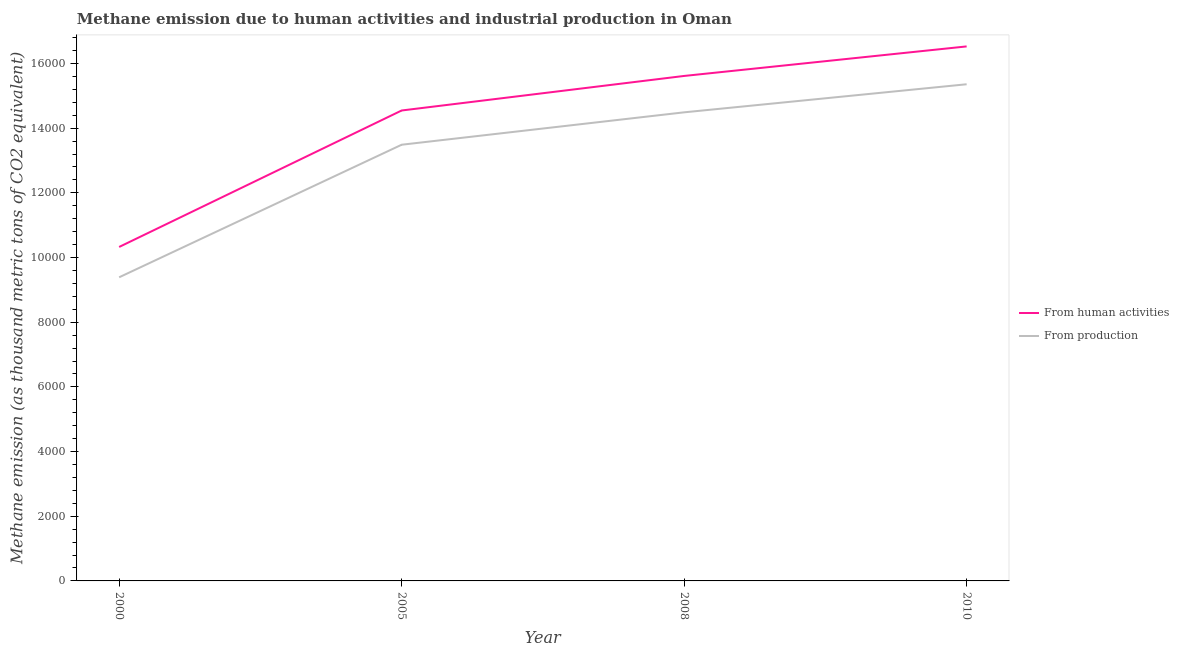Is the number of lines equal to the number of legend labels?
Provide a short and direct response. Yes. What is the amount of emissions from human activities in 2008?
Your answer should be compact. 1.56e+04. Across all years, what is the maximum amount of emissions generated from industries?
Make the answer very short. 1.54e+04. Across all years, what is the minimum amount of emissions from human activities?
Your answer should be compact. 1.03e+04. In which year was the amount of emissions generated from industries maximum?
Your response must be concise. 2010. What is the total amount of emissions from human activities in the graph?
Ensure brevity in your answer.  5.70e+04. What is the difference between the amount of emissions generated from industries in 2000 and that in 2005?
Ensure brevity in your answer.  -4099. What is the difference between the amount of emissions generated from industries in 2000 and the amount of emissions from human activities in 2010?
Keep it short and to the point. -7138.8. What is the average amount of emissions generated from industries per year?
Provide a short and direct response. 1.32e+04. In the year 2000, what is the difference between the amount of emissions generated from industries and amount of emissions from human activities?
Make the answer very short. -937.9. In how many years, is the amount of emissions from human activities greater than 1600 thousand metric tons?
Your response must be concise. 4. What is the ratio of the amount of emissions generated from industries in 2000 to that in 2008?
Provide a succinct answer. 0.65. Is the amount of emissions generated from industries in 2000 less than that in 2010?
Keep it short and to the point. Yes. Is the difference between the amount of emissions from human activities in 2005 and 2008 greater than the difference between the amount of emissions generated from industries in 2005 and 2008?
Make the answer very short. No. What is the difference between the highest and the second highest amount of emissions generated from industries?
Provide a succinct answer. 868. What is the difference between the highest and the lowest amount of emissions from human activities?
Make the answer very short. 6200.9. In how many years, is the amount of emissions generated from industries greater than the average amount of emissions generated from industries taken over all years?
Your answer should be very brief. 3. Does the amount of emissions from human activities monotonically increase over the years?
Offer a very short reply. Yes. What is the difference between two consecutive major ticks on the Y-axis?
Provide a short and direct response. 2000. Does the graph contain grids?
Your response must be concise. No. What is the title of the graph?
Your answer should be compact. Methane emission due to human activities and industrial production in Oman. What is the label or title of the X-axis?
Provide a succinct answer. Year. What is the label or title of the Y-axis?
Your answer should be very brief. Methane emission (as thousand metric tons of CO2 equivalent). What is the Methane emission (as thousand metric tons of CO2 equivalent) of From human activities in 2000?
Offer a very short reply. 1.03e+04. What is the Methane emission (as thousand metric tons of CO2 equivalent) of From production in 2000?
Provide a succinct answer. 9388.4. What is the Methane emission (as thousand metric tons of CO2 equivalent) of From human activities in 2005?
Keep it short and to the point. 1.45e+04. What is the Methane emission (as thousand metric tons of CO2 equivalent) of From production in 2005?
Provide a succinct answer. 1.35e+04. What is the Methane emission (as thousand metric tons of CO2 equivalent) of From human activities in 2008?
Your answer should be compact. 1.56e+04. What is the Methane emission (as thousand metric tons of CO2 equivalent) in From production in 2008?
Keep it short and to the point. 1.45e+04. What is the Methane emission (as thousand metric tons of CO2 equivalent) of From human activities in 2010?
Ensure brevity in your answer.  1.65e+04. What is the Methane emission (as thousand metric tons of CO2 equivalent) in From production in 2010?
Your answer should be compact. 1.54e+04. Across all years, what is the maximum Methane emission (as thousand metric tons of CO2 equivalent) of From human activities?
Make the answer very short. 1.65e+04. Across all years, what is the maximum Methane emission (as thousand metric tons of CO2 equivalent) of From production?
Ensure brevity in your answer.  1.54e+04. Across all years, what is the minimum Methane emission (as thousand metric tons of CO2 equivalent) of From human activities?
Offer a terse response. 1.03e+04. Across all years, what is the minimum Methane emission (as thousand metric tons of CO2 equivalent) of From production?
Keep it short and to the point. 9388.4. What is the total Methane emission (as thousand metric tons of CO2 equivalent) of From human activities in the graph?
Give a very brief answer. 5.70e+04. What is the total Methane emission (as thousand metric tons of CO2 equivalent) in From production in the graph?
Make the answer very short. 5.27e+04. What is the difference between the Methane emission (as thousand metric tons of CO2 equivalent) of From human activities in 2000 and that in 2005?
Make the answer very short. -4219.8. What is the difference between the Methane emission (as thousand metric tons of CO2 equivalent) of From production in 2000 and that in 2005?
Your answer should be compact. -4099. What is the difference between the Methane emission (as thousand metric tons of CO2 equivalent) in From human activities in 2000 and that in 2008?
Provide a succinct answer. -5288. What is the difference between the Methane emission (as thousand metric tons of CO2 equivalent) of From production in 2000 and that in 2008?
Your answer should be very brief. -5100.8. What is the difference between the Methane emission (as thousand metric tons of CO2 equivalent) in From human activities in 2000 and that in 2010?
Your response must be concise. -6200.9. What is the difference between the Methane emission (as thousand metric tons of CO2 equivalent) in From production in 2000 and that in 2010?
Your answer should be very brief. -5968.8. What is the difference between the Methane emission (as thousand metric tons of CO2 equivalent) of From human activities in 2005 and that in 2008?
Your response must be concise. -1068.2. What is the difference between the Methane emission (as thousand metric tons of CO2 equivalent) of From production in 2005 and that in 2008?
Keep it short and to the point. -1001.8. What is the difference between the Methane emission (as thousand metric tons of CO2 equivalent) in From human activities in 2005 and that in 2010?
Offer a very short reply. -1981.1. What is the difference between the Methane emission (as thousand metric tons of CO2 equivalent) in From production in 2005 and that in 2010?
Your answer should be very brief. -1869.8. What is the difference between the Methane emission (as thousand metric tons of CO2 equivalent) in From human activities in 2008 and that in 2010?
Keep it short and to the point. -912.9. What is the difference between the Methane emission (as thousand metric tons of CO2 equivalent) in From production in 2008 and that in 2010?
Offer a terse response. -868. What is the difference between the Methane emission (as thousand metric tons of CO2 equivalent) of From human activities in 2000 and the Methane emission (as thousand metric tons of CO2 equivalent) of From production in 2005?
Your answer should be compact. -3161.1. What is the difference between the Methane emission (as thousand metric tons of CO2 equivalent) of From human activities in 2000 and the Methane emission (as thousand metric tons of CO2 equivalent) of From production in 2008?
Your answer should be very brief. -4162.9. What is the difference between the Methane emission (as thousand metric tons of CO2 equivalent) in From human activities in 2000 and the Methane emission (as thousand metric tons of CO2 equivalent) in From production in 2010?
Provide a succinct answer. -5030.9. What is the difference between the Methane emission (as thousand metric tons of CO2 equivalent) of From human activities in 2005 and the Methane emission (as thousand metric tons of CO2 equivalent) of From production in 2008?
Your answer should be very brief. 56.9. What is the difference between the Methane emission (as thousand metric tons of CO2 equivalent) of From human activities in 2005 and the Methane emission (as thousand metric tons of CO2 equivalent) of From production in 2010?
Your answer should be compact. -811.1. What is the difference between the Methane emission (as thousand metric tons of CO2 equivalent) in From human activities in 2008 and the Methane emission (as thousand metric tons of CO2 equivalent) in From production in 2010?
Provide a short and direct response. 257.1. What is the average Methane emission (as thousand metric tons of CO2 equivalent) in From human activities per year?
Your response must be concise. 1.43e+04. What is the average Methane emission (as thousand metric tons of CO2 equivalent) in From production per year?
Your answer should be compact. 1.32e+04. In the year 2000, what is the difference between the Methane emission (as thousand metric tons of CO2 equivalent) in From human activities and Methane emission (as thousand metric tons of CO2 equivalent) in From production?
Give a very brief answer. 937.9. In the year 2005, what is the difference between the Methane emission (as thousand metric tons of CO2 equivalent) of From human activities and Methane emission (as thousand metric tons of CO2 equivalent) of From production?
Give a very brief answer. 1058.7. In the year 2008, what is the difference between the Methane emission (as thousand metric tons of CO2 equivalent) of From human activities and Methane emission (as thousand metric tons of CO2 equivalent) of From production?
Make the answer very short. 1125.1. In the year 2010, what is the difference between the Methane emission (as thousand metric tons of CO2 equivalent) in From human activities and Methane emission (as thousand metric tons of CO2 equivalent) in From production?
Give a very brief answer. 1170. What is the ratio of the Methane emission (as thousand metric tons of CO2 equivalent) in From human activities in 2000 to that in 2005?
Your answer should be compact. 0.71. What is the ratio of the Methane emission (as thousand metric tons of CO2 equivalent) of From production in 2000 to that in 2005?
Keep it short and to the point. 0.7. What is the ratio of the Methane emission (as thousand metric tons of CO2 equivalent) of From human activities in 2000 to that in 2008?
Ensure brevity in your answer.  0.66. What is the ratio of the Methane emission (as thousand metric tons of CO2 equivalent) in From production in 2000 to that in 2008?
Your answer should be compact. 0.65. What is the ratio of the Methane emission (as thousand metric tons of CO2 equivalent) of From human activities in 2000 to that in 2010?
Your response must be concise. 0.62. What is the ratio of the Methane emission (as thousand metric tons of CO2 equivalent) in From production in 2000 to that in 2010?
Offer a terse response. 0.61. What is the ratio of the Methane emission (as thousand metric tons of CO2 equivalent) of From human activities in 2005 to that in 2008?
Offer a terse response. 0.93. What is the ratio of the Methane emission (as thousand metric tons of CO2 equivalent) of From production in 2005 to that in 2008?
Offer a terse response. 0.93. What is the ratio of the Methane emission (as thousand metric tons of CO2 equivalent) in From human activities in 2005 to that in 2010?
Offer a terse response. 0.88. What is the ratio of the Methane emission (as thousand metric tons of CO2 equivalent) of From production in 2005 to that in 2010?
Keep it short and to the point. 0.88. What is the ratio of the Methane emission (as thousand metric tons of CO2 equivalent) in From human activities in 2008 to that in 2010?
Offer a very short reply. 0.94. What is the ratio of the Methane emission (as thousand metric tons of CO2 equivalent) of From production in 2008 to that in 2010?
Give a very brief answer. 0.94. What is the difference between the highest and the second highest Methane emission (as thousand metric tons of CO2 equivalent) of From human activities?
Provide a short and direct response. 912.9. What is the difference between the highest and the second highest Methane emission (as thousand metric tons of CO2 equivalent) in From production?
Provide a short and direct response. 868. What is the difference between the highest and the lowest Methane emission (as thousand metric tons of CO2 equivalent) in From human activities?
Your answer should be compact. 6200.9. What is the difference between the highest and the lowest Methane emission (as thousand metric tons of CO2 equivalent) in From production?
Make the answer very short. 5968.8. 